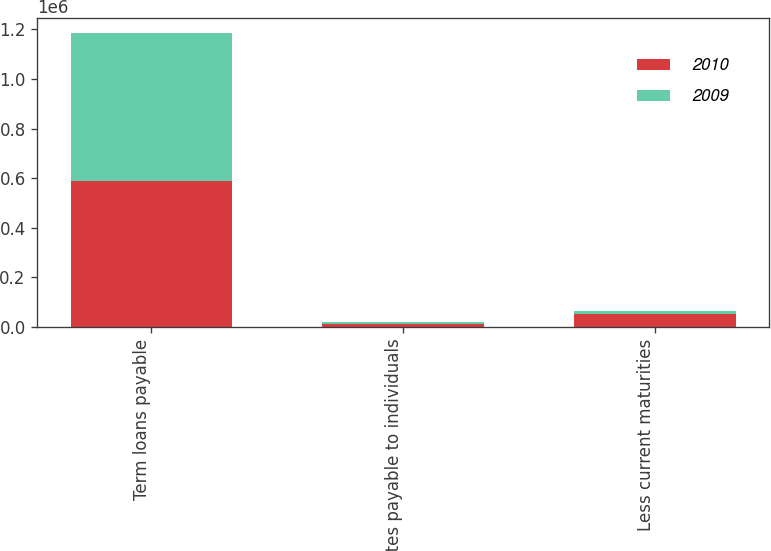<chart> <loc_0><loc_0><loc_500><loc_500><stacked_bar_chart><ecel><fcel>Term loans payable<fcel>Notes payable to individuals<fcel>Less current maturities<nl><fcel>2010<fcel>590099<fcel>10855<fcel>52888<nl><fcel>2009<fcel>595716<fcel>7329<fcel>10063<nl></chart> 